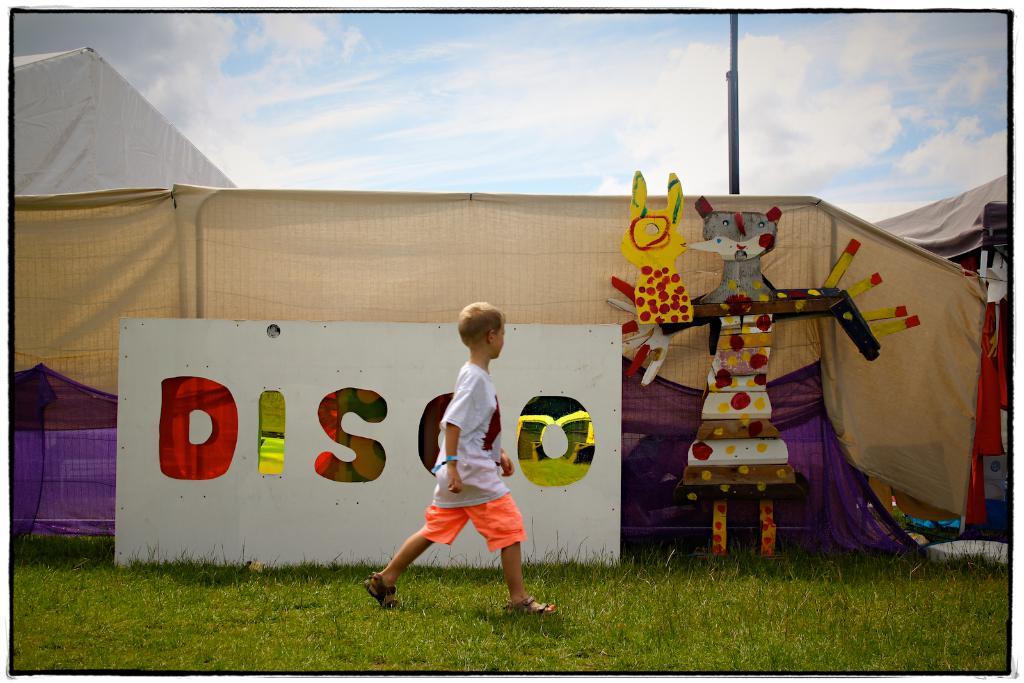What kind of dance is mentioned?
Keep it short and to the point. Disco. What word is on the sign?
Offer a terse response. Disco. 